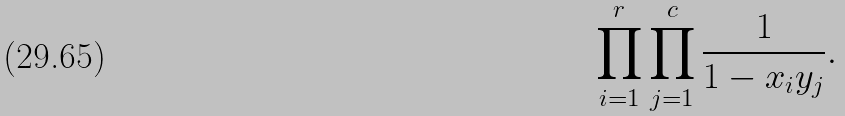<formula> <loc_0><loc_0><loc_500><loc_500>\prod _ { i = 1 } ^ { r } \prod _ { j = 1 } ^ { c } { \frac { 1 } { 1 - x _ { i } y _ { j } } } .</formula> 